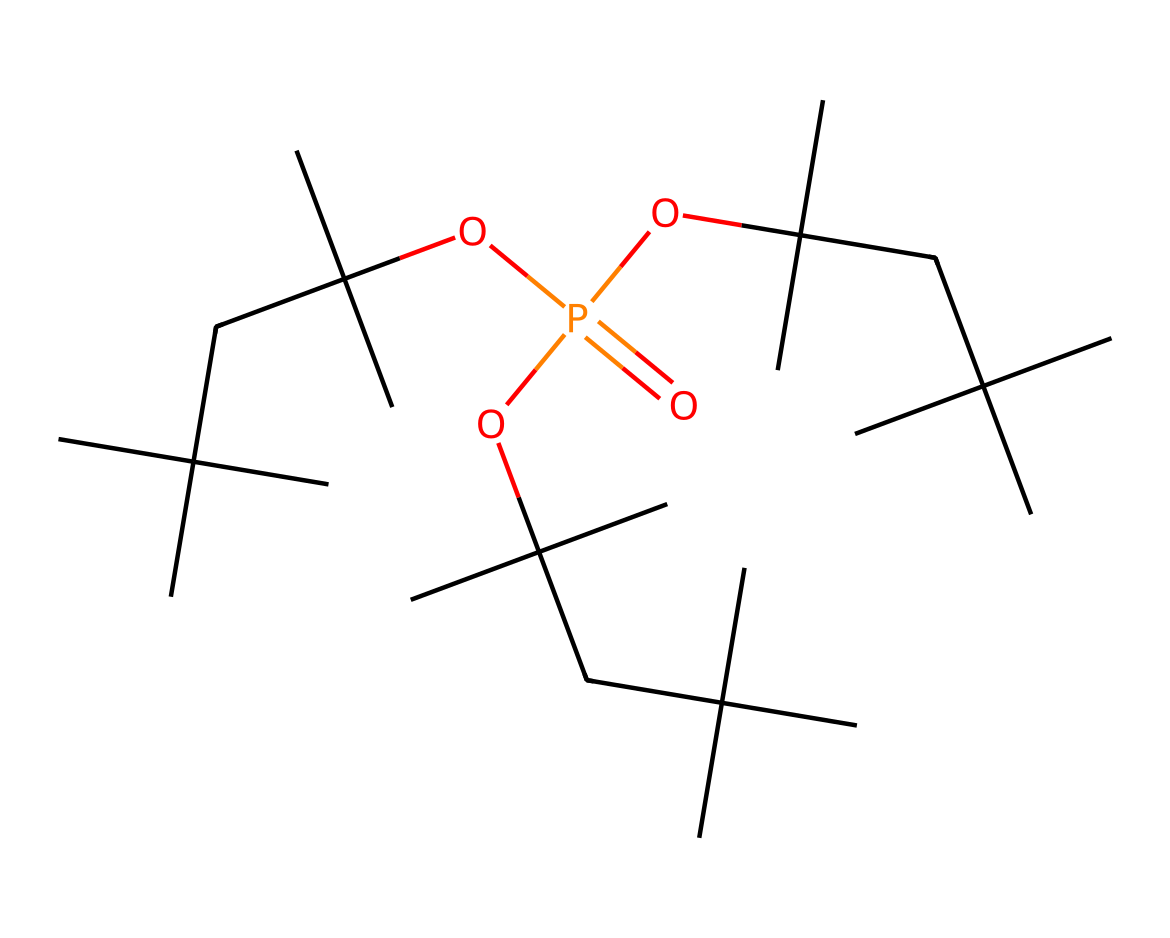What is the central atom in this chemical? The central atom in the chemical structure is phosphorus, which is indicated by the positioning of the atom in the structure.
Answer: phosphorus How many ester functional groups are present in this chemical? The chemical shows multiple alkoxy groups (OC), which are characteristic of ester functional groups. Each alkoxy group indicates one ester, and since there are three of them, there are three ester functional groups.
Answer: three What is the overall molecular formula derived from the SMILES? Analyzing the structure, the number of carbon (C), hydrogen (H), oxygen (O), and phosphorus (P) atoms can be counted. The total count provides the molecular formula as C27H57O4P.
Answer: C27H57O4P What type of chemical compound is this? This chemical is classified as an organophosphorus compound, indicated by the presence of phosphorus bonded to organic groups (alkyl chains here).
Answer: organophosphorus compound How many carbon atoms are in this compound? By examining the structure represented by the SMILES, we can count the carbon atoms, which total 27 when all branches are included.
Answer: 27 What property makes this chemical useful as a flame retardant? The phosphorus atom in the structure plays a crucial role in flame retardancy by promoting char formation and reducing flammability, which is a key factor in its use as a suppressor of fire.
Answer: char formation Is this compound likely to be soluble in water? Given the long hydrocarbon chains and the presence of phosphorus in the structure, this compound is expected to be hydrophobic or poorly soluble in water, as the non-polar alkyl chains dominate over the polar ether linkages.
Answer: unlikely 